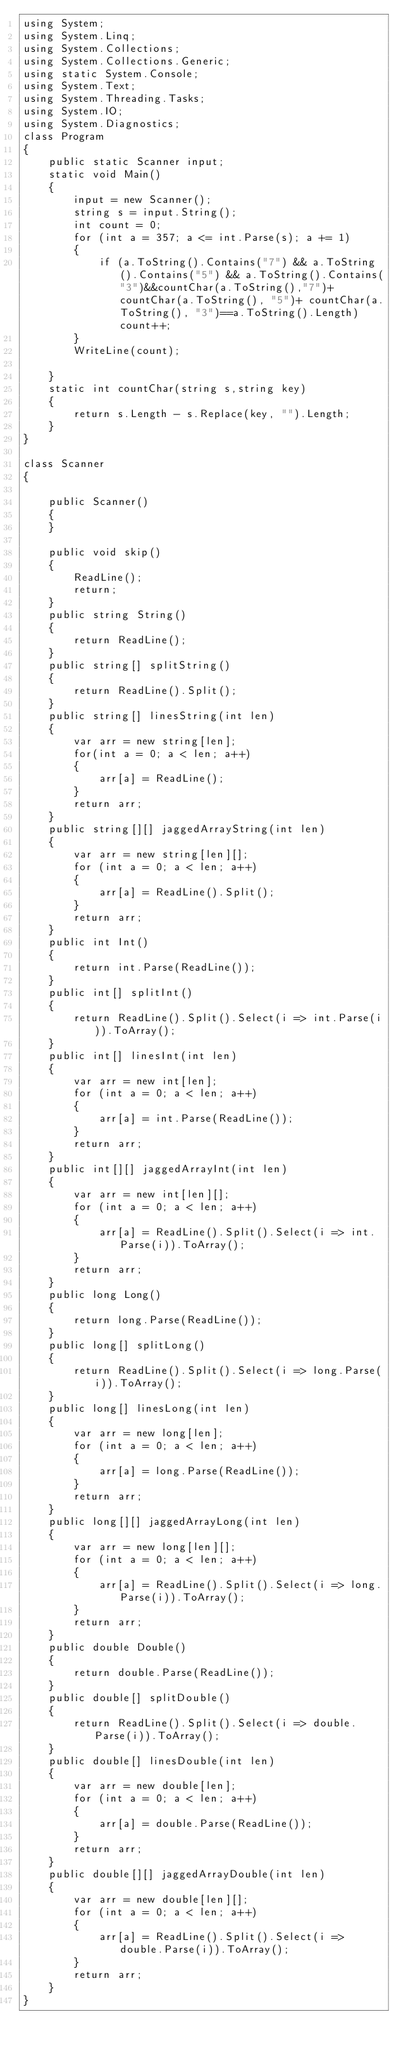Convert code to text. <code><loc_0><loc_0><loc_500><loc_500><_C#_>using System;
using System.Linq;
using System.Collections;
using System.Collections.Generic;
using static System.Console;
using System.Text;
using System.Threading.Tasks;
using System.IO;
using System.Diagnostics;
class Program
{
    public static Scanner input;
    static void Main()
    {
        input = new Scanner();
        string s = input.String();
        int count = 0;
        for (int a = 357; a <= int.Parse(s); a += 1)
        {
            if (a.ToString().Contains("7") && a.ToString().Contains("5") && a.ToString().Contains("3")&&countChar(a.ToString(),"7")+ countChar(a.ToString(), "5")+ countChar(a.ToString(), "3")==a.ToString().Length) count++;
        }
        WriteLine(count);

    }
    static int countChar(string s,string key)
    {
        return s.Length - s.Replace(key, "").Length;
    }
}

class Scanner
{

    public Scanner()
    {
    }

    public void skip()
    {
        ReadLine();
        return;
    }
    public string String()
    {
        return ReadLine();
    }
    public string[] splitString()
    {
        return ReadLine().Split();
    }
    public string[] linesString(int len)
    {
        var arr = new string[len];
        for(int a = 0; a < len; a++)
        {
            arr[a] = ReadLine();
        }
        return arr;
    }
    public string[][] jaggedArrayString(int len)
    {
        var arr = new string[len][];
        for (int a = 0; a < len; a++)
        {
            arr[a] = ReadLine().Split();
        }
        return arr;
    }
    public int Int()
    {
        return int.Parse(ReadLine());
    }
    public int[] splitInt()
    {
        return ReadLine().Split().Select(i => int.Parse(i)).ToArray();
    }
    public int[] linesInt(int len)
    {
        var arr = new int[len];
        for (int a = 0; a < len; a++)
        {
            arr[a] = int.Parse(ReadLine());
        }
        return arr;
    }
    public int[][] jaggedArrayInt(int len)
    {
        var arr = new int[len][];
        for (int a = 0; a < len; a++)
        {
            arr[a] = ReadLine().Split().Select(i => int.Parse(i)).ToArray();
        }
        return arr;
    }
    public long Long()
    {
        return long.Parse(ReadLine());
    }
    public long[] splitLong()
    {
        return ReadLine().Split().Select(i => long.Parse(i)).ToArray();
    }
    public long[] linesLong(int len)
    {
        var arr = new long[len];
        for (int a = 0; a < len; a++)
        {
            arr[a] = long.Parse(ReadLine());
        }
        return arr;
    }
    public long[][] jaggedArrayLong(int len)
    {
        var arr = new long[len][];
        for (int a = 0; a < len; a++)
        {
            arr[a] = ReadLine().Split().Select(i => long.Parse(i)).ToArray();
        }
        return arr;
    }
    public double Double()
    {
        return double.Parse(ReadLine());
    }
    public double[] splitDouble()
    {
        return ReadLine().Split().Select(i => double.Parse(i)).ToArray();
    }
    public double[] linesDouble(int len)
    {
        var arr = new double[len];
        for (int a = 0; a < len; a++)
        {
            arr[a] = double.Parse(ReadLine());
        }
        return arr;
    }
    public double[][] jaggedArrayDouble(int len)
    {
        var arr = new double[len][];
        for (int a = 0; a < len; a++)
        {
            arr[a] = ReadLine().Split().Select(i => double.Parse(i)).ToArray();
        }
        return arr;
    }
}</code> 